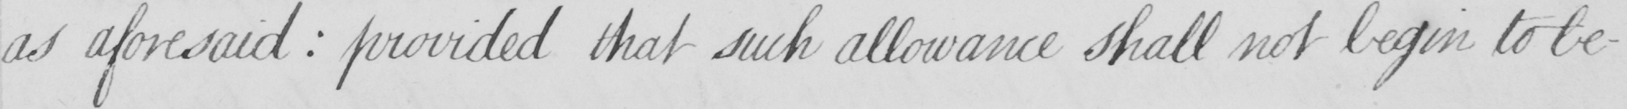Transcribe the text shown in this historical manuscript line. as aforesaid  :  provided that such allowance shall not begin to be- 